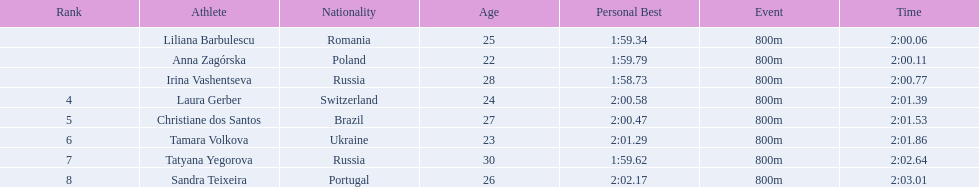What were all the finishing times? 2:00.06, 2:00.11, 2:00.77, 2:01.39, 2:01.53, 2:01.86, 2:02.64, 2:03.01. Which of these is anna zagorska's? 2:00.11. 